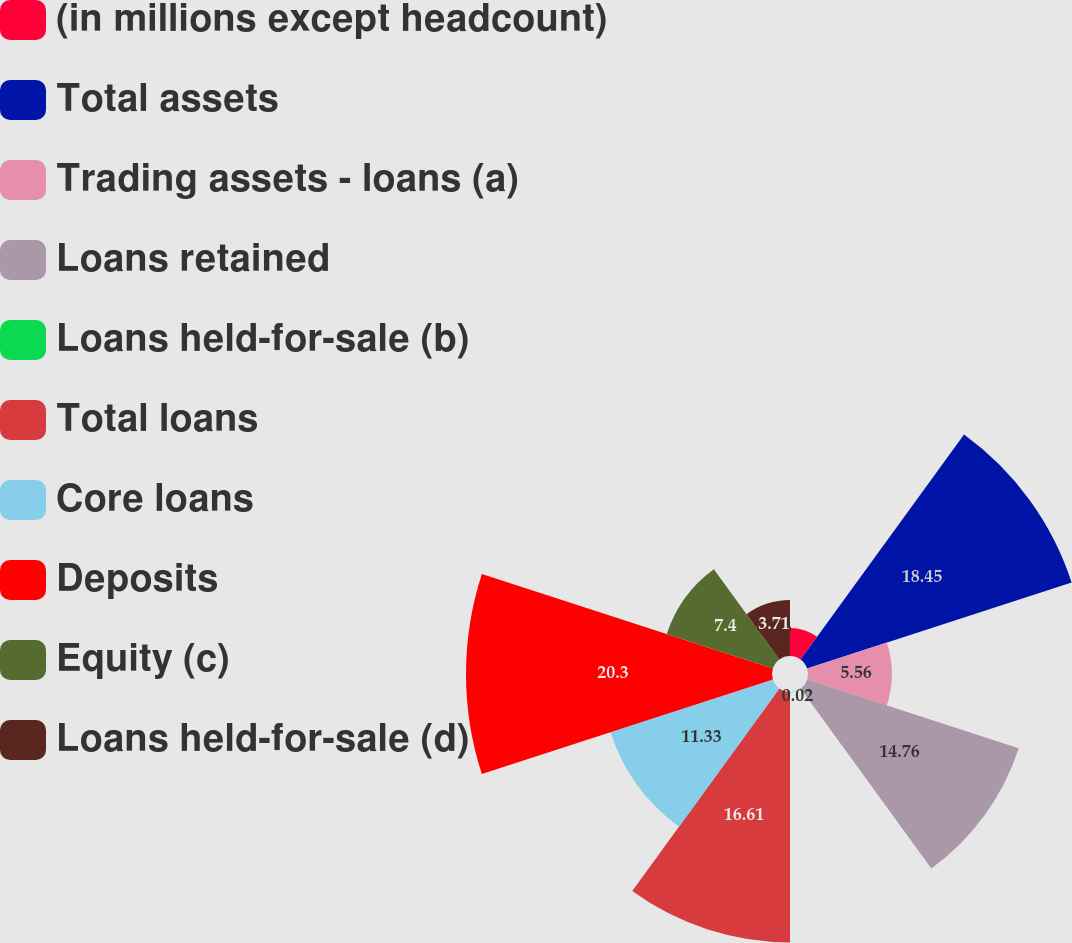Convert chart to OTSL. <chart><loc_0><loc_0><loc_500><loc_500><pie_chart><fcel>(in millions except headcount)<fcel>Total assets<fcel>Trading assets - loans (a)<fcel>Loans retained<fcel>Loans held-for-sale (b)<fcel>Total loans<fcel>Core loans<fcel>Deposits<fcel>Equity (c)<fcel>Loans held-for-sale (d)<nl><fcel>1.86%<fcel>18.45%<fcel>5.56%<fcel>14.76%<fcel>0.02%<fcel>16.61%<fcel>11.33%<fcel>20.3%<fcel>7.4%<fcel>3.71%<nl></chart> 